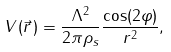Convert formula to latex. <formula><loc_0><loc_0><loc_500><loc_500>V ( \vec { r } \, ) = \frac { \Lambda ^ { 2 } } { 2 \pi \rho _ { s } } \frac { \cos ( 2 \varphi ) } { r ^ { 2 } } ,</formula> 